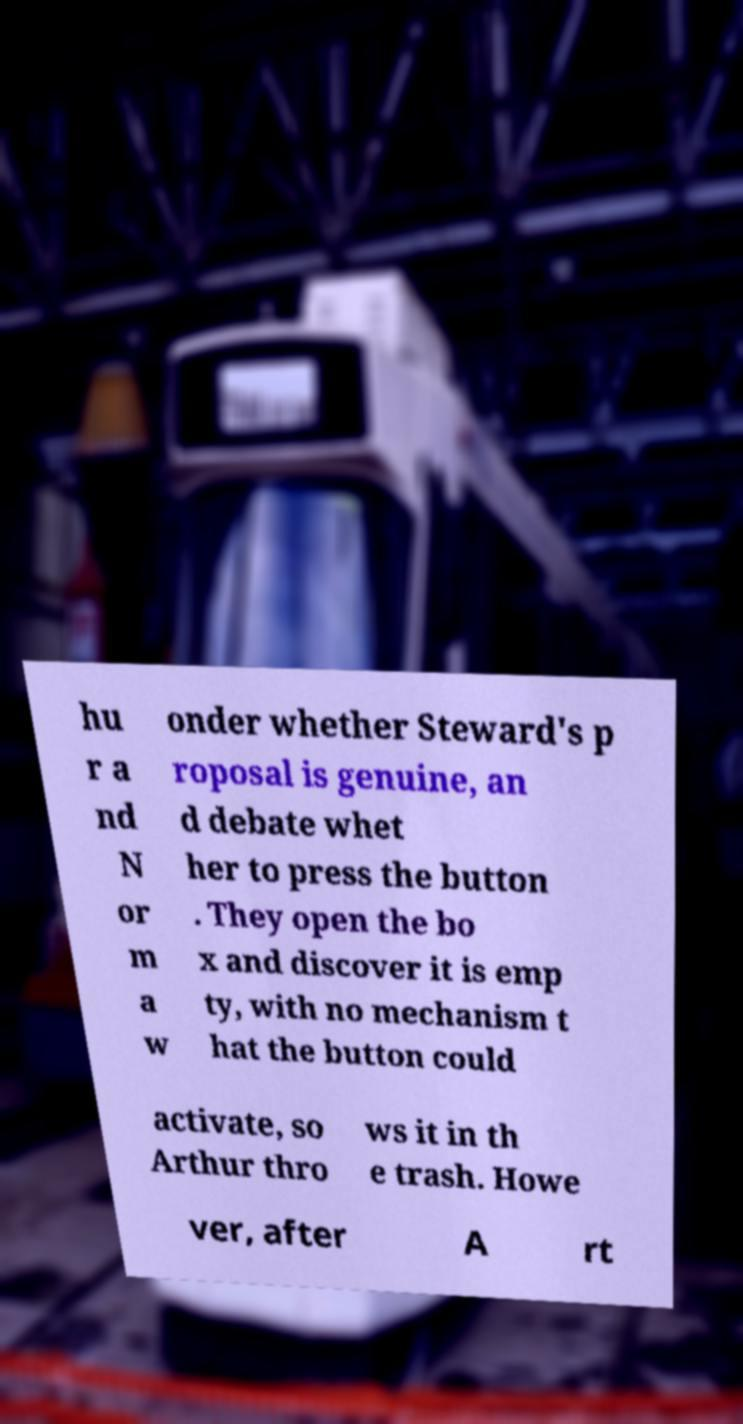For documentation purposes, I need the text within this image transcribed. Could you provide that? hu r a nd N or m a w onder whether Steward's p roposal is genuine, an d debate whet her to press the button . They open the bo x and discover it is emp ty, with no mechanism t hat the button could activate, so Arthur thro ws it in th e trash. Howe ver, after A rt 